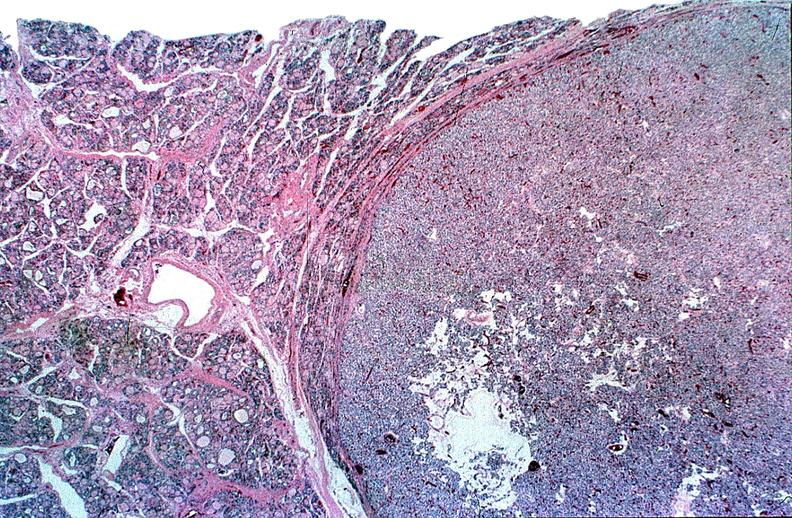does acute lymphocytic leukemia show thyroid, follicular ademona?
Answer the question using a single word or phrase. No 